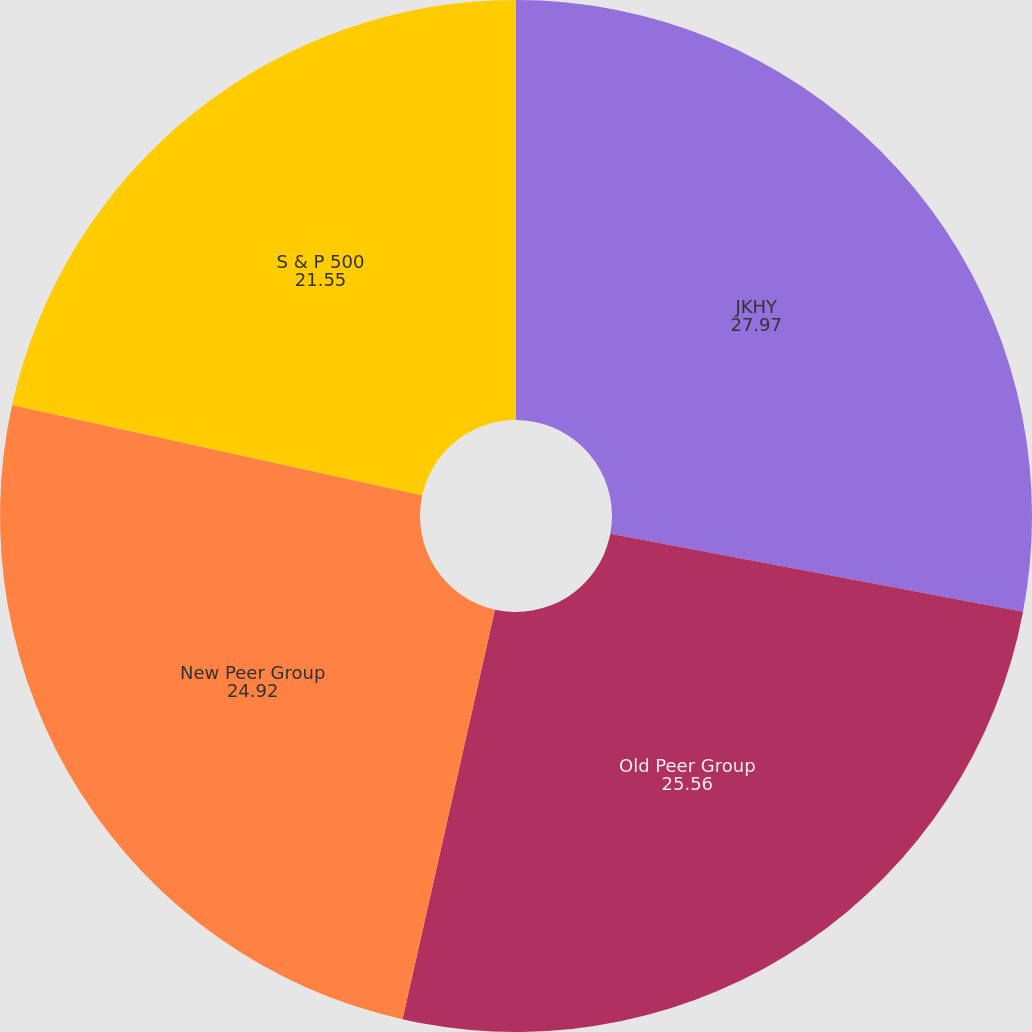<chart> <loc_0><loc_0><loc_500><loc_500><pie_chart><fcel>JKHY<fcel>Old Peer Group<fcel>New Peer Group<fcel>S & P 500<nl><fcel>27.97%<fcel>25.56%<fcel>24.92%<fcel>21.55%<nl></chart> 